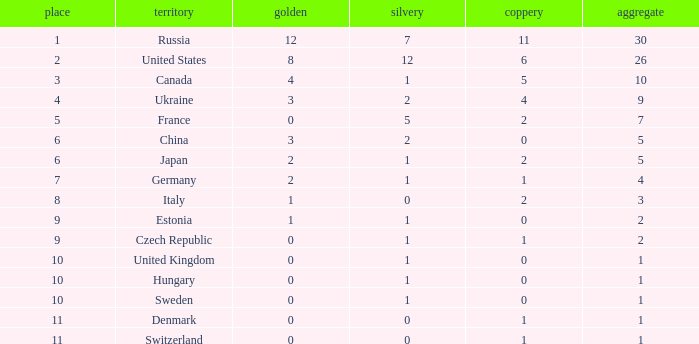Which silver has a Gold smaller than 12, a Rank smaller than 5, and a Bronze of 5? 1.0. 